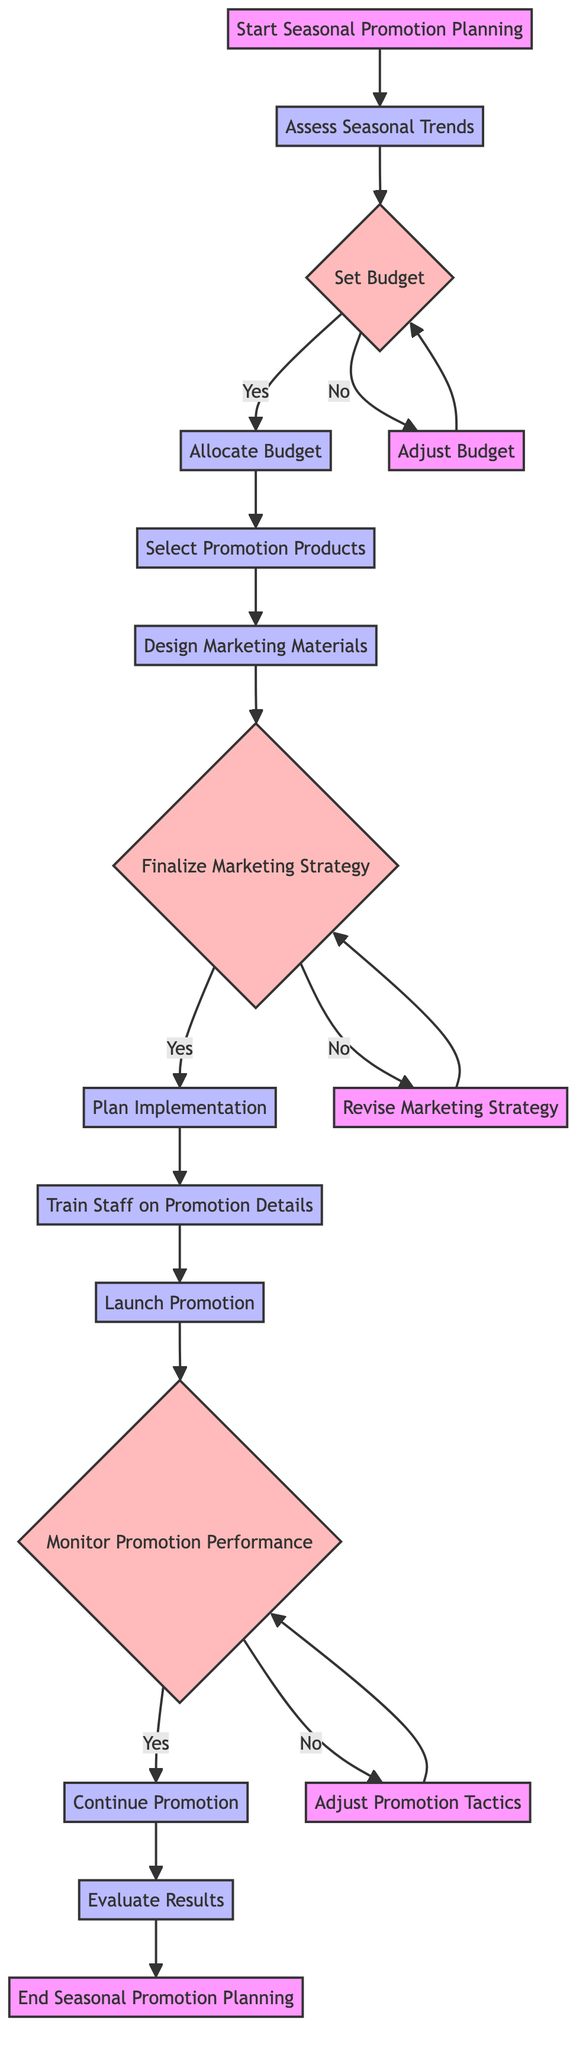What is the first step in the promotion planning process? The diagram indicates that the first step, labeled "Start Seasonal Promotion Planning", is where the process begins.
Answer: Start Seasonal Promotion Planning How many decision points are there in the diagram? By analyzing the diagram, we identify three decision points: "Set Budget", "Finalize Marketing Strategy", and "Monitor Promotion Performance". Thus, there are three decision points total.
Answer: 3 What happens if the marketing budget is not sufficient? If the marketing budget is not sufficient, the flow moves to the node "Adjust Budget", which indicates that adjustments must be made to the budget before proceeding.
Answer: Adjust Budget What is the process that follows after "Train Staff on Promotion Details"? After "Train Staff on Promotion Details", the next process in the flow is "Launch Promotion", indicating that the training is completed before launching the promotion.
Answer: Launch Promotion What is the last node in the diagram? The last node in the diagram is labeled "End Seasonal Promotion Planning", marking the conclusion of the promotion planning process.
Answer: End Seasonal Promotion Planning If the marketing strategy is not approved, what node will it return to? If the marketing strategy is not approved, the flow returns to the node labeled "Revise Marketing Strategy", signifying that revisions need to be made before approval.
Answer: Revise Marketing Strategy What is the main focus of the "Assess Seasonal Trends" process? The "Assess Seasonal Trends" process focuses on analyzing popular nail designs and colors anticipated for the upcoming season, informing decisions for the promotion.
Answer: Analyze popular nail designs and colors What do you do if the promotion is performing successfully? If the promotion is performing successfully, the flow indicates to "Continue Promotion", suggesting that no changes are needed and the promotion should continue as planned.
Answer: Continue Promotion 